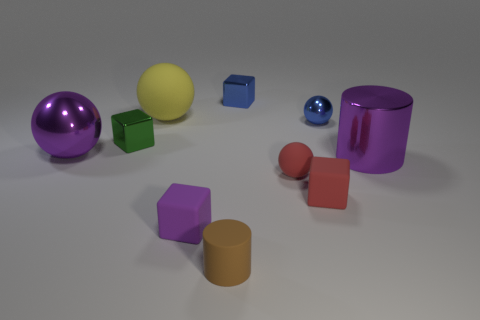Subtract all cylinders. How many objects are left? 8 Add 1 tiny purple matte things. How many tiny purple matte things exist? 2 Subtract 0 gray cylinders. How many objects are left? 10 Subtract all large matte objects. Subtract all purple matte blocks. How many objects are left? 8 Add 1 metal things. How many metal things are left? 6 